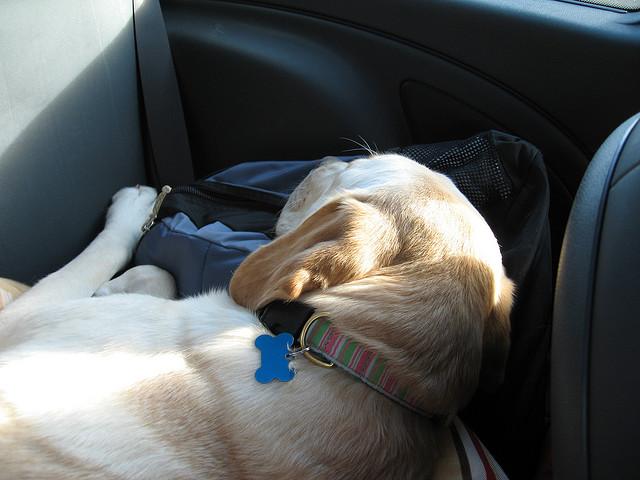What type of animal is this?
Answer briefly. Dog. Where is the blue tag?
Keep it brief. On collar. Where is the dog sleeping?
Be succinct. Car. 